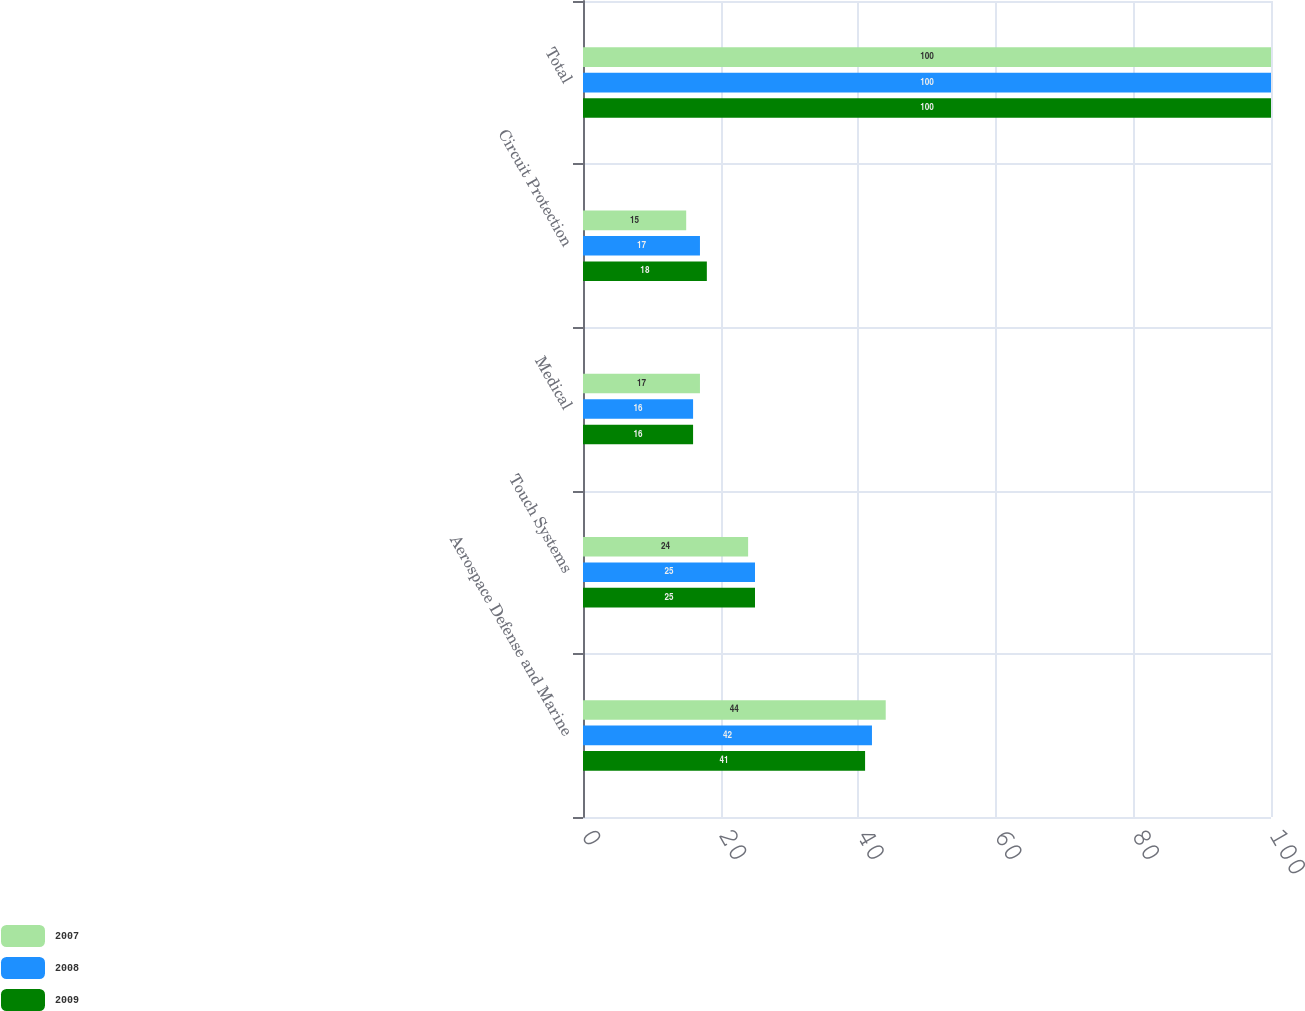Convert chart to OTSL. <chart><loc_0><loc_0><loc_500><loc_500><stacked_bar_chart><ecel><fcel>Aerospace Defense and Marine<fcel>Touch Systems<fcel>Medical<fcel>Circuit Protection<fcel>Total<nl><fcel>2007<fcel>44<fcel>24<fcel>17<fcel>15<fcel>100<nl><fcel>2008<fcel>42<fcel>25<fcel>16<fcel>17<fcel>100<nl><fcel>2009<fcel>41<fcel>25<fcel>16<fcel>18<fcel>100<nl></chart> 